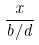<formula> <loc_0><loc_0><loc_500><loc_500>\frac { x } { b / d }</formula> 